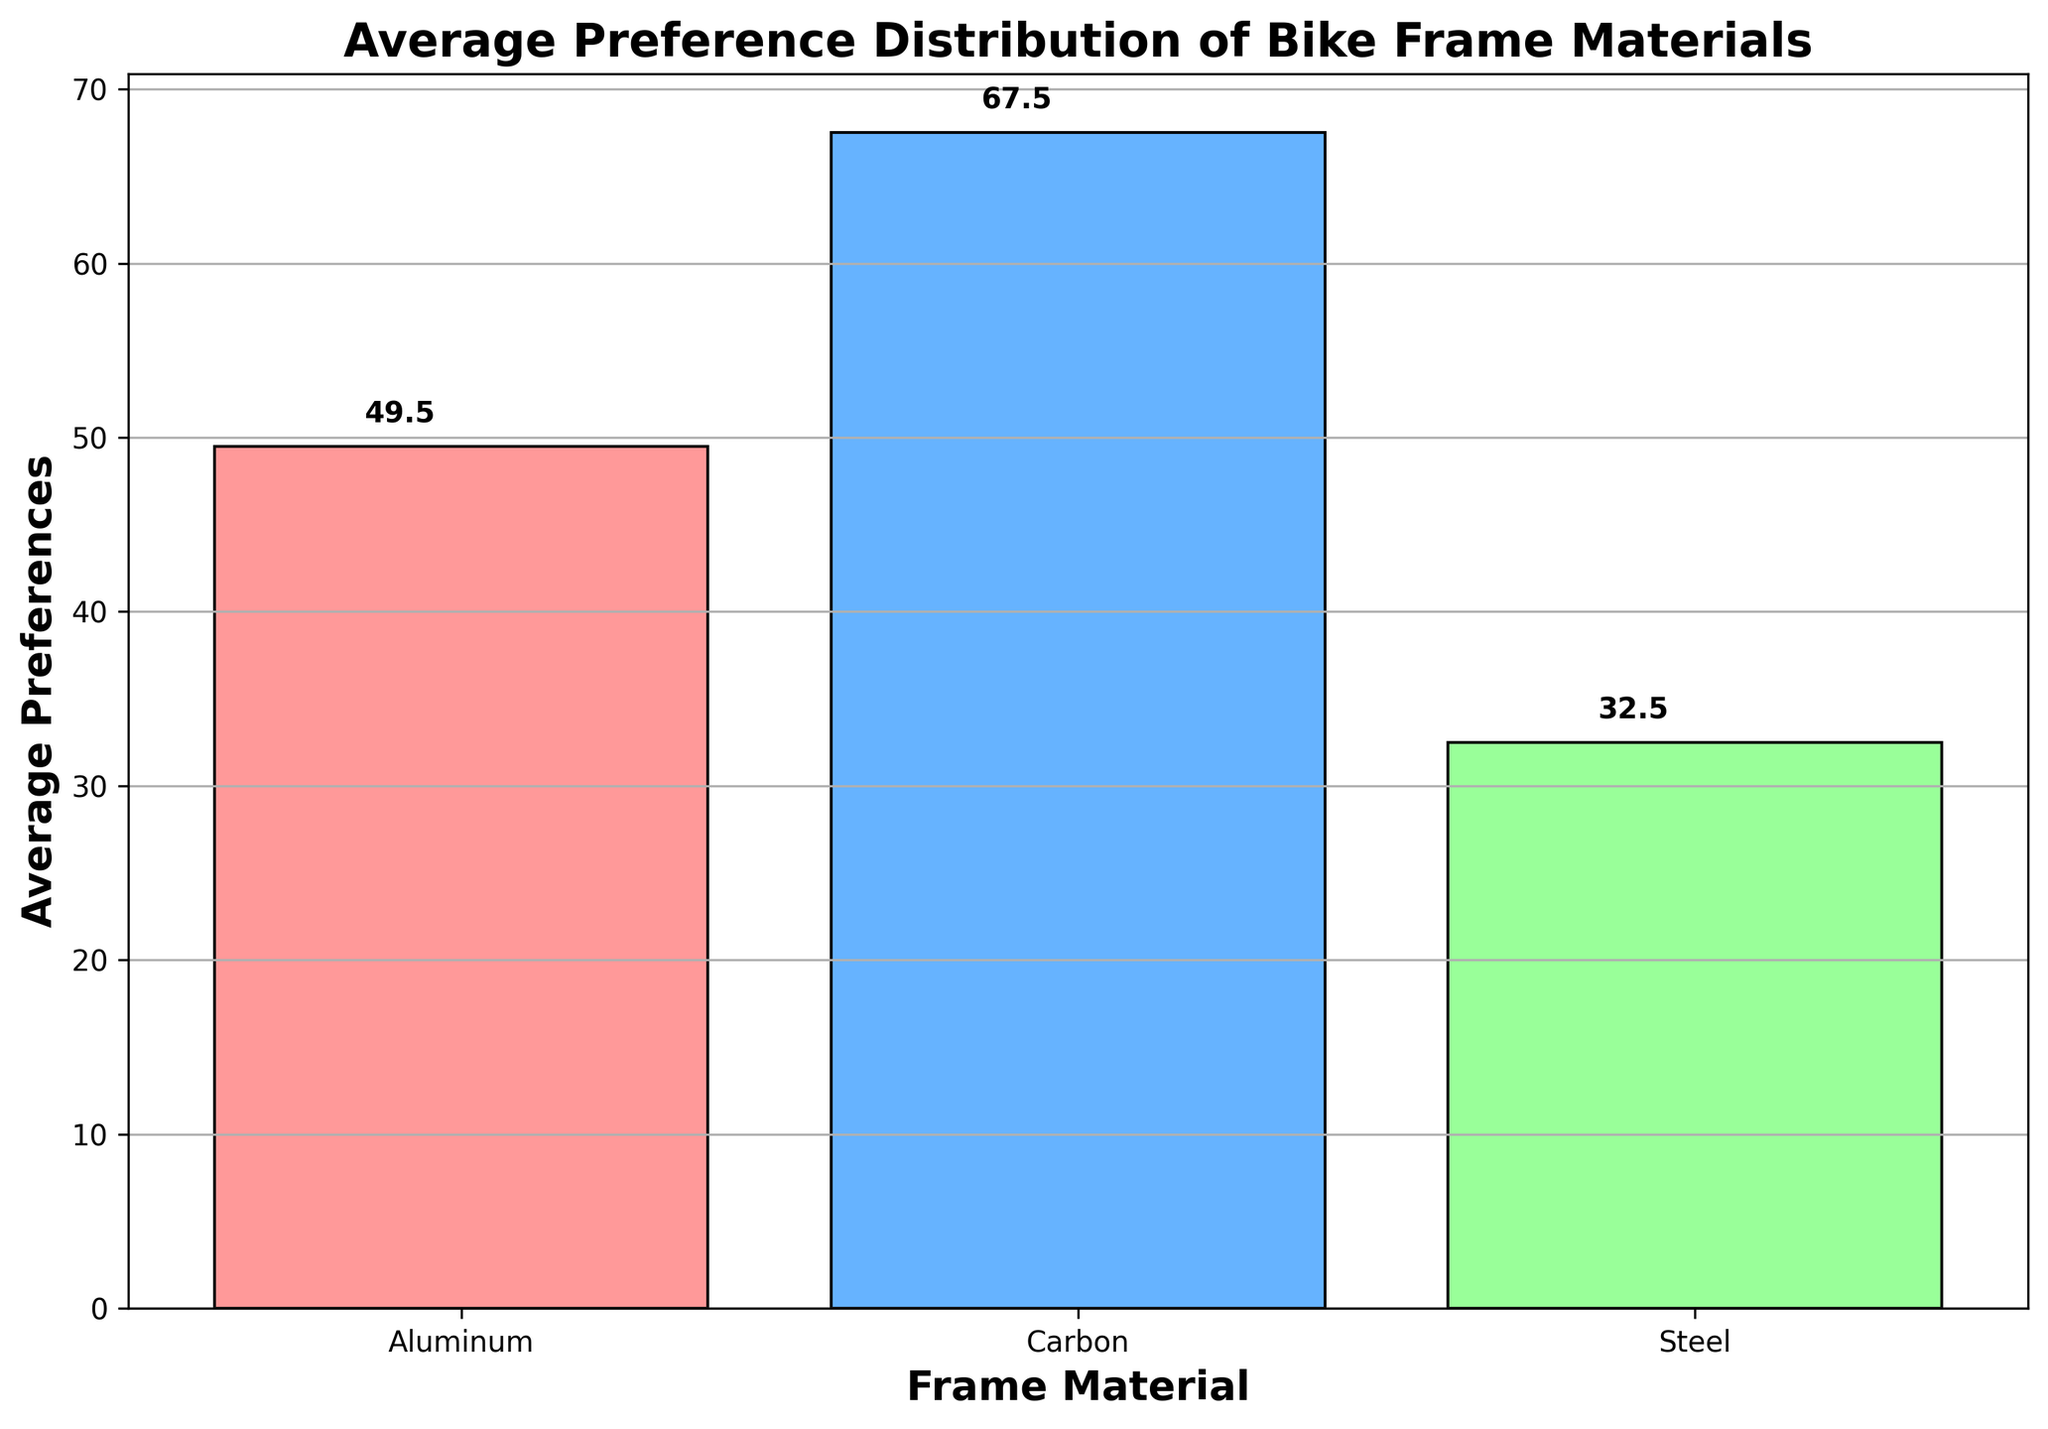What's the average preference for Carbon frame material? The average preference for Carbon can be directly read off from the bar chart. Look for the bar labeled "Carbon" and note its height.
Answer: 67.5 Which frame material shows the lowest average preference? Check the heights of all the bars and identify the one with the smallest height.
Answer: Steel What is the total average preference for Aluminum and Steel? Find the average preferences for Aluminum and Steel from the chart, then add them: 49.5 (Aluminum) + 32.5 (Steel) = 82.
Answer: 82 How much higher is the average preference for Carbon compared to Steel? Calculate the difference between the average preferences of Carbon and Steel: 67.5 (Carbon) - 32.5 (Steel) = 35.
Answer: 35 What is the average of the average preferences of all frame materials? Compute the mean of all average preferences: (49.5 + 67.5 + 32.5) / 3 = 149.5 / 3 = 49.8.
Answer: 49.8 Which frame material has the second highest average preference? Examine the heights of bars and rank them. Carbon has the highest, and Aluminum is the second highest.
Answer: Aluminum How do the heights of the bars for Aluminum and Carbon compare visually? Visually inspect and describe the heights of the bars for Aluminum and Carbon. Carbon's bar is taller than Aluminum's bar.
Answer: Carbon's bar is taller By how much do the average preferences of Aluminum and Carbon differ? Calculate the difference between their average preferences: 67.5 (Carbon) - 49.5 (Aluminum) = 18.
Answer: 18 What color is used to represent Steel in the chart? Identify the color of the bar labeled "Steel"
Answer: Green If the preference for Aluminum decreased by 5, what would its new value be compared to Steel? Subtract 5 from Aluminum's average preference: 49.5 - 5 = 44.5, which is still greater than Steel's 32.5.
Answer: 44.5, and it would still be greater than Steel 